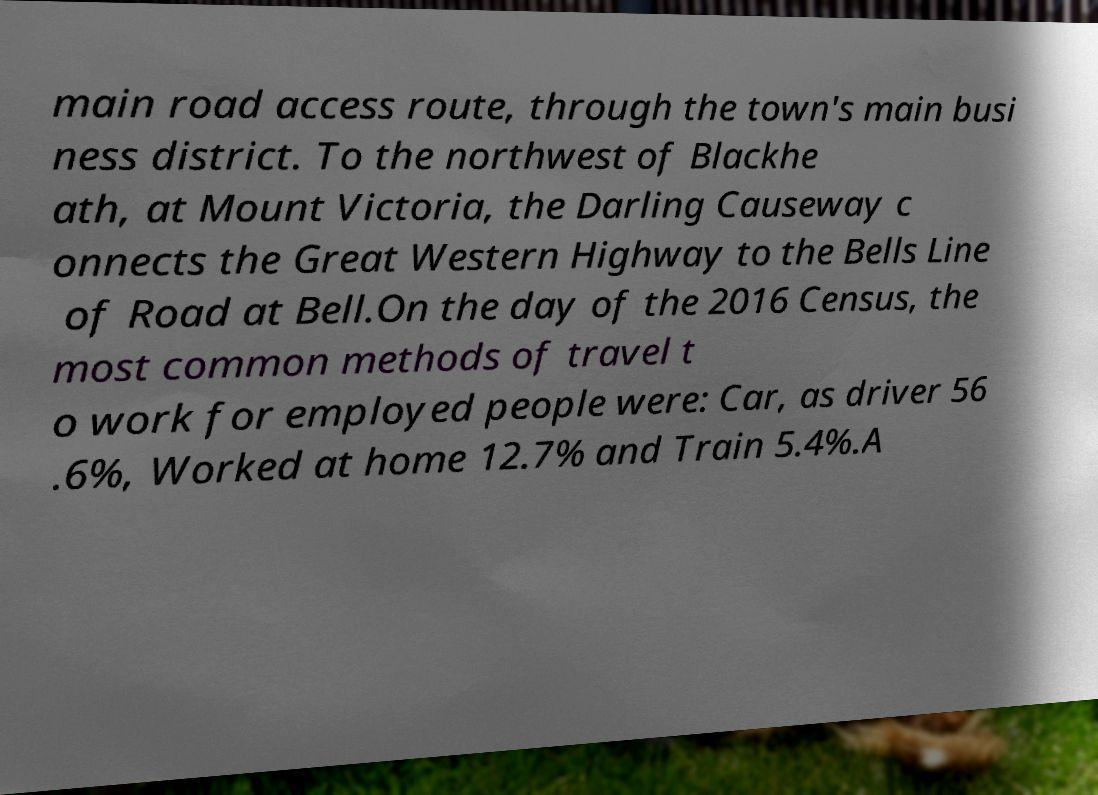Could you assist in decoding the text presented in this image and type it out clearly? main road access route, through the town's main busi ness district. To the northwest of Blackhe ath, at Mount Victoria, the Darling Causeway c onnects the Great Western Highway to the Bells Line of Road at Bell.On the day of the 2016 Census, the most common methods of travel t o work for employed people were: Car, as driver 56 .6%, Worked at home 12.7% and Train 5.4%.A 